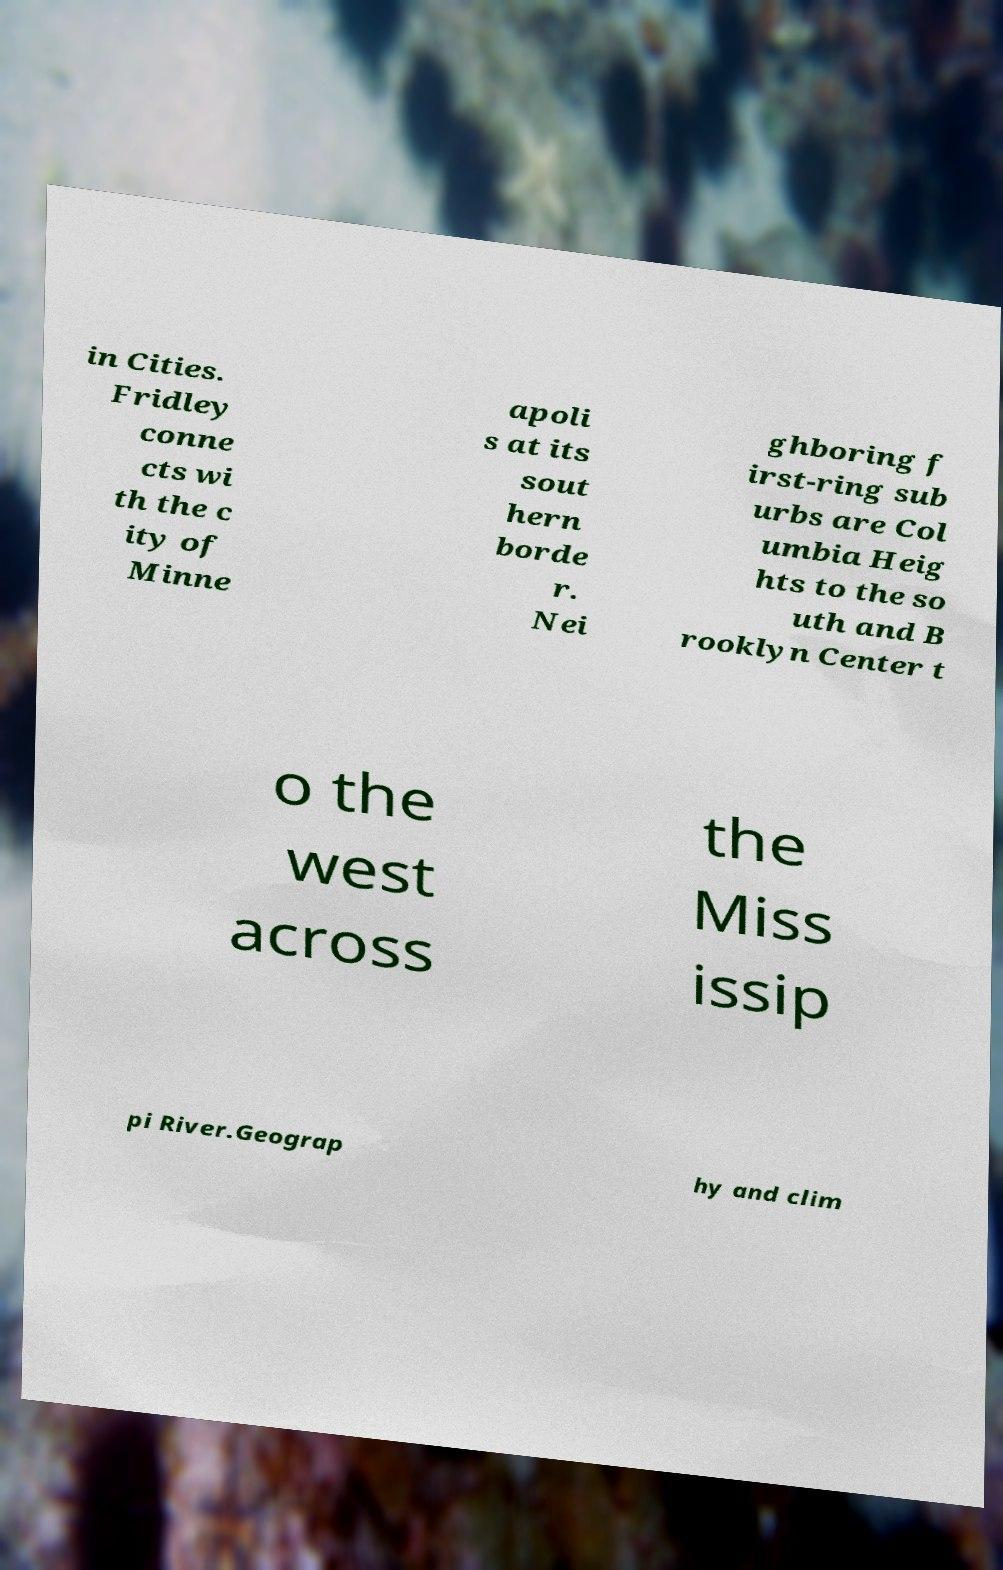Could you extract and type out the text from this image? in Cities. Fridley conne cts wi th the c ity of Minne apoli s at its sout hern borde r. Nei ghboring f irst-ring sub urbs are Col umbia Heig hts to the so uth and B rooklyn Center t o the west across the Miss issip pi River.Geograp hy and clim 